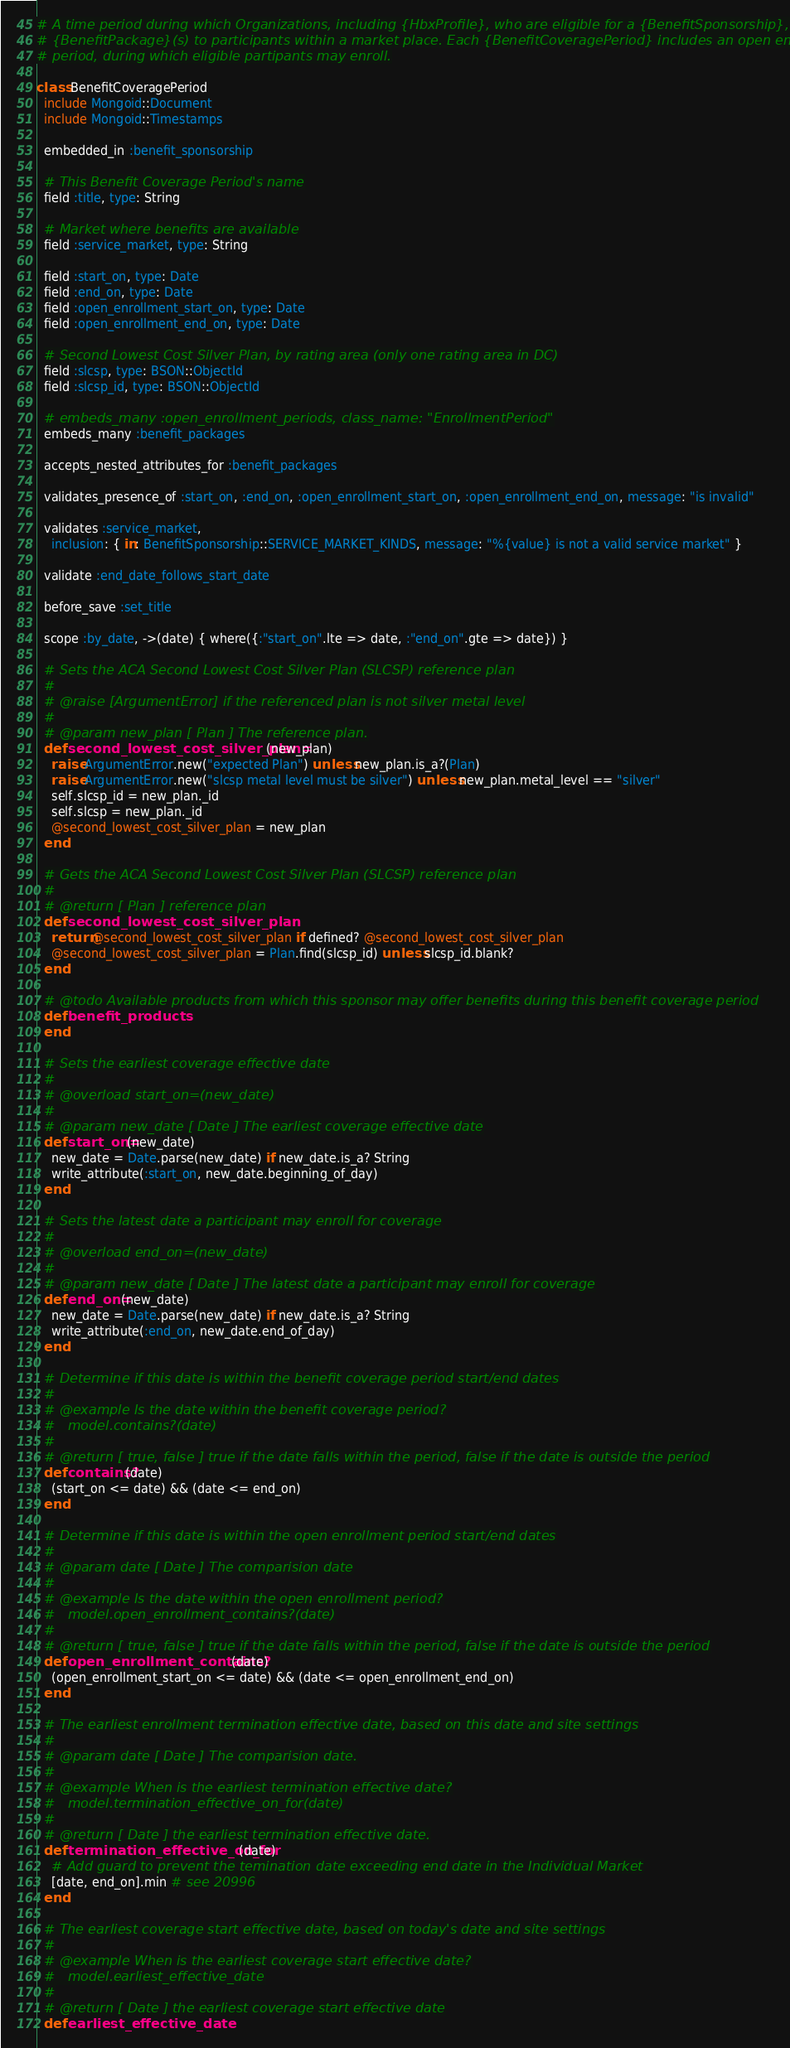<code> <loc_0><loc_0><loc_500><loc_500><_Ruby_># A time period during which Organizations, including {HbxProfile}, who are eligible for a {BenefitSponsorship}, may offer
# {BenefitPackage}(s) to participants within a market place. Each {BenefitCoveragePeriod} includes an open enrollment
# period, during which eligible partipants may enroll.

class BenefitCoveragePeriod
  include Mongoid::Document
  include Mongoid::Timestamps

  embedded_in :benefit_sponsorship

  # This Benefit Coverage Period's name
  field :title, type: String

  # Market where benefits are available
  field :service_market, type: String

  field :start_on, type: Date
  field :end_on, type: Date
  field :open_enrollment_start_on, type: Date
  field :open_enrollment_end_on, type: Date

  # Second Lowest Cost Silver Plan, by rating area (only one rating area in DC)
  field :slcsp, type: BSON::ObjectId
  field :slcsp_id, type: BSON::ObjectId

  # embeds_many :open_enrollment_periods, class_name: "EnrollmentPeriod"
  embeds_many :benefit_packages

  accepts_nested_attributes_for :benefit_packages

  validates_presence_of :start_on, :end_on, :open_enrollment_start_on, :open_enrollment_end_on, message: "is invalid"

  validates :service_market,
    inclusion: { in: BenefitSponsorship::SERVICE_MARKET_KINDS, message: "%{value} is not a valid service market" }

  validate :end_date_follows_start_date

  before_save :set_title

  scope :by_date, ->(date) { where({:"start_on".lte => date, :"end_on".gte => date}) }

  # Sets the ACA Second Lowest Cost Silver Plan (SLCSP) reference plan
  #
  # @raise [ArgumentError] if the referenced plan is not silver metal level
  #
  # @param new_plan [ Plan ] The reference plan.
  def second_lowest_cost_silver_plan=(new_plan)
    raise ArgumentError.new("expected Plan") unless new_plan.is_a?(Plan)
    raise ArgumentError.new("slcsp metal level must be silver") unless new_plan.metal_level == "silver"
    self.slcsp_id = new_plan._id
    self.slcsp = new_plan._id
    @second_lowest_cost_silver_plan = new_plan
  end

  # Gets the ACA Second Lowest Cost Silver Plan (SLCSP) reference plan
  #
  # @return [ Plan ] reference plan
  def second_lowest_cost_silver_plan
    return @second_lowest_cost_silver_plan if defined? @second_lowest_cost_silver_plan
    @second_lowest_cost_silver_plan = Plan.find(slcsp_id) unless slcsp_id.blank?
  end

  # @todo Available products from which this sponsor may offer benefits during this benefit coverage period
  def benefit_products
  end

  # Sets the earliest coverage effective date
  #
  # @overload start_on=(new_date)
  #
  # @param new_date [ Date ] The earliest coverage effective date
  def start_on=(new_date)
    new_date = Date.parse(new_date) if new_date.is_a? String
    write_attribute(:start_on, new_date.beginning_of_day)
  end

  # Sets the latest date a participant may enroll for coverage
  #
  # @overload end_on=(new_date)
  #
  # @param new_date [ Date ] The latest date a participant may enroll for coverage
  def end_on=(new_date)
    new_date = Date.parse(new_date) if new_date.is_a? String
    write_attribute(:end_on, new_date.end_of_day)
  end

  # Determine if this date is within the benefit coverage period start/end dates
  #
  # @example Is the date within the benefit coverage period?
  #   model.contains?(date)
  #
  # @return [ true, false ] true if the date falls within the period, false if the date is outside the period
  def contains?(date)
    (start_on <= date) && (date <= end_on)
  end

  # Determine if this date is within the open enrollment period start/end dates
  #
  # @param date [ Date ] The comparision date
  #
  # @example Is the date within the open enrollment period?
  #   model.open_enrollment_contains?(date)
  #
  # @return [ true, false ] true if the date falls within the period, false if the date is outside the period
  def open_enrollment_contains?(date)
    (open_enrollment_start_on <= date) && (date <= open_enrollment_end_on)
  end

  # The earliest enrollment termination effective date, based on this date and site settings
  #
  # @param date [ Date ] The comparision date.
  #
  # @example When is the earliest termination effective date?
  #   model.termination_effective_on_for(date)
  #
  # @return [ Date ] the earliest termination effective date.
  def termination_effective_on_for(date)
    # Add guard to prevent the temination date exceeding end date in the Individual Market
    [date, end_on].min # see 20996
  end

  # The earliest coverage start effective date, based on today's date and site settings
  #
  # @example When is the earliest coverage start effective date?
  #   model.earliest_effective_date
  #
  # @return [ Date ] the earliest coverage start effective date
  def earliest_effective_date</code> 